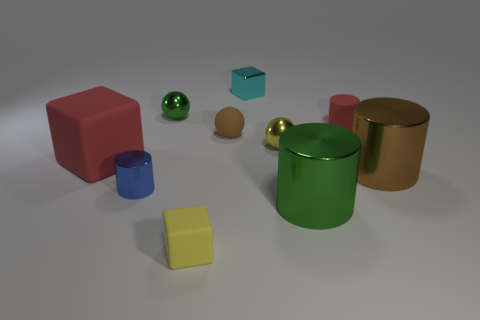Subtract all yellow blocks. How many blocks are left? 2 Subtract 1 spheres. How many spheres are left? 2 Subtract all red cylinders. How many cylinders are left? 3 Subtract all balls. How many objects are left? 7 Subtract all cyan balls. Subtract all purple cylinders. How many balls are left? 3 Subtract all spheres. Subtract all large metallic objects. How many objects are left? 5 Add 8 small rubber spheres. How many small rubber spheres are left? 9 Add 7 big blue cylinders. How many big blue cylinders exist? 7 Subtract 1 brown cylinders. How many objects are left? 9 